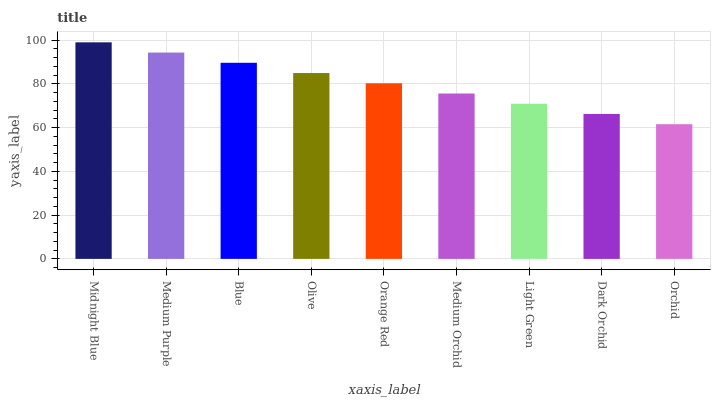Is Orchid the minimum?
Answer yes or no. Yes. Is Midnight Blue the maximum?
Answer yes or no. Yes. Is Medium Purple the minimum?
Answer yes or no. No. Is Medium Purple the maximum?
Answer yes or no. No. Is Midnight Blue greater than Medium Purple?
Answer yes or no. Yes. Is Medium Purple less than Midnight Blue?
Answer yes or no. Yes. Is Medium Purple greater than Midnight Blue?
Answer yes or no. No. Is Midnight Blue less than Medium Purple?
Answer yes or no. No. Is Orange Red the high median?
Answer yes or no. Yes. Is Orange Red the low median?
Answer yes or no. Yes. Is Midnight Blue the high median?
Answer yes or no. No. Is Olive the low median?
Answer yes or no. No. 